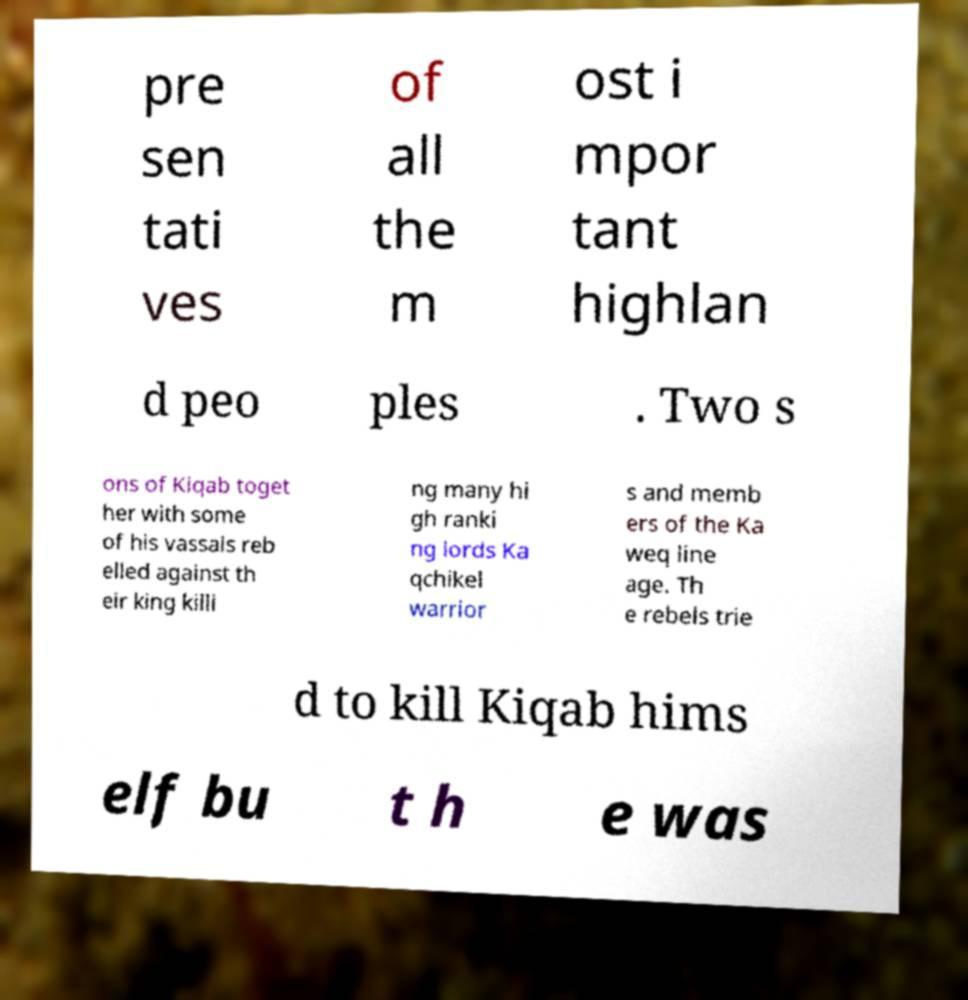Can you accurately transcribe the text from the provided image for me? pre sen tati ves of all the m ost i mpor tant highlan d peo ples . Two s ons of Kiqab toget her with some of his vassals reb elled against th eir king killi ng many hi gh ranki ng lords Ka qchikel warrior s and memb ers of the Ka weq line age. Th e rebels trie d to kill Kiqab hims elf bu t h e was 